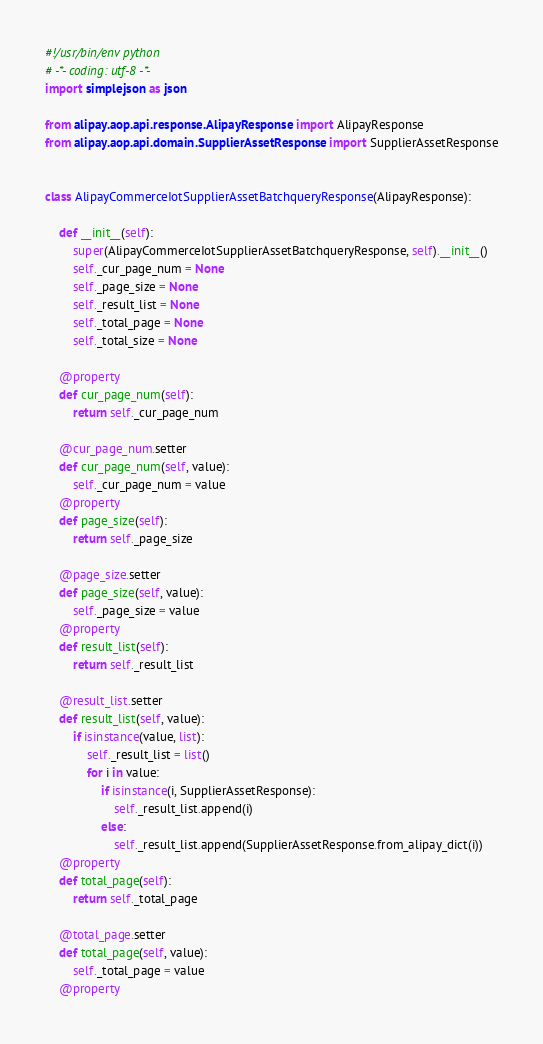Convert code to text. <code><loc_0><loc_0><loc_500><loc_500><_Python_>#!/usr/bin/env python
# -*- coding: utf-8 -*-
import simplejson as json

from alipay.aop.api.response.AlipayResponse import AlipayResponse
from alipay.aop.api.domain.SupplierAssetResponse import SupplierAssetResponse


class AlipayCommerceIotSupplierAssetBatchqueryResponse(AlipayResponse):

    def __init__(self):
        super(AlipayCommerceIotSupplierAssetBatchqueryResponse, self).__init__()
        self._cur_page_num = None
        self._page_size = None
        self._result_list = None
        self._total_page = None
        self._total_size = None

    @property
    def cur_page_num(self):
        return self._cur_page_num

    @cur_page_num.setter
    def cur_page_num(self, value):
        self._cur_page_num = value
    @property
    def page_size(self):
        return self._page_size

    @page_size.setter
    def page_size(self, value):
        self._page_size = value
    @property
    def result_list(self):
        return self._result_list

    @result_list.setter
    def result_list(self, value):
        if isinstance(value, list):
            self._result_list = list()
            for i in value:
                if isinstance(i, SupplierAssetResponse):
                    self._result_list.append(i)
                else:
                    self._result_list.append(SupplierAssetResponse.from_alipay_dict(i))
    @property
    def total_page(self):
        return self._total_page

    @total_page.setter
    def total_page(self, value):
        self._total_page = value
    @property</code> 